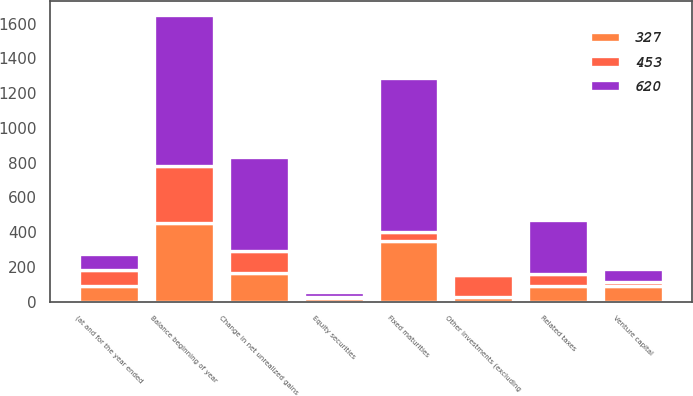Convert chart to OTSL. <chart><loc_0><loc_0><loc_500><loc_500><stacked_bar_chart><ecel><fcel>(at and for the year ended<fcel>Fixed maturities<fcel>Equity securities<fcel>Venture capital<fcel>Other investments (excluding<fcel>Related taxes<fcel>Change in net unrealized gains<fcel>Balance beginning of year<nl><fcel>327<fcel>91<fcel>346<fcel>22<fcel>91<fcel>25<fcel>91<fcel>167<fcel>453<nl><fcel>453<fcel>91<fcel>55<fcel>4<fcel>19<fcel>125<fcel>69<fcel>126<fcel>327<nl><fcel>620<fcel>91<fcel>885<fcel>31<fcel>78<fcel>14<fcel>311<fcel>541<fcel>868<nl></chart> 